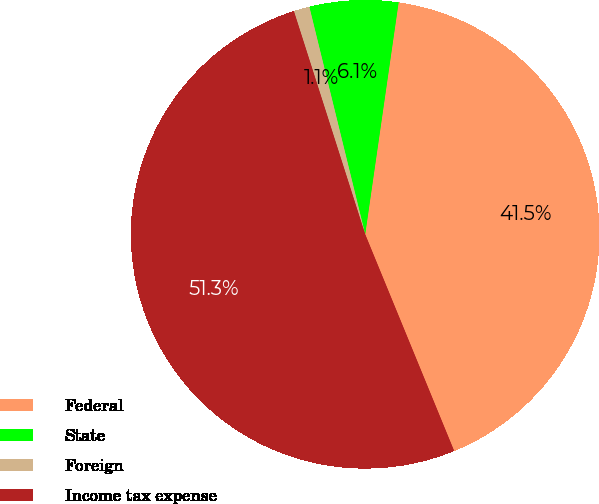Convert chart. <chart><loc_0><loc_0><loc_500><loc_500><pie_chart><fcel>Federal<fcel>State<fcel>Foreign<fcel>Income tax expense<nl><fcel>41.52%<fcel>6.11%<fcel>1.09%<fcel>51.28%<nl></chart> 